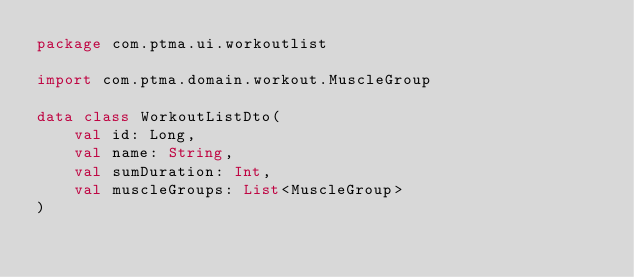<code> <loc_0><loc_0><loc_500><loc_500><_Kotlin_>package com.ptma.ui.workoutlist

import com.ptma.domain.workout.MuscleGroup

data class WorkoutListDto(
    val id: Long,
    val name: String,
    val sumDuration: Int,
    val muscleGroups: List<MuscleGroup>
)</code> 